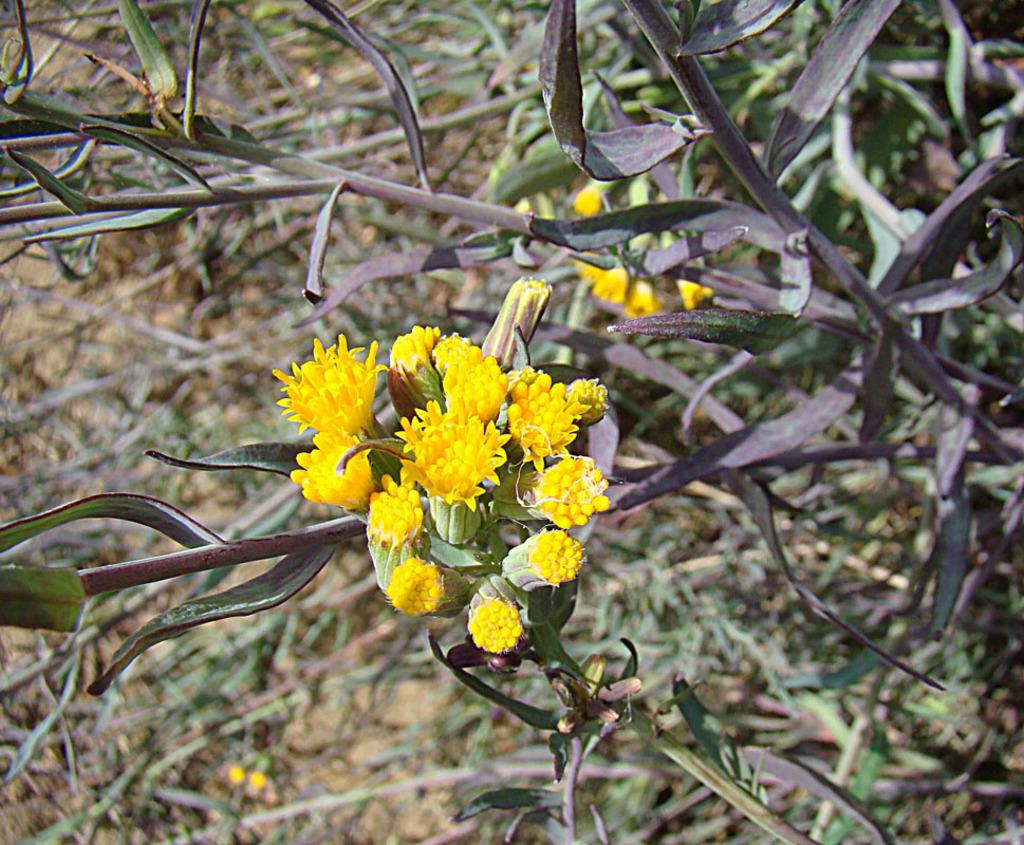What type of living organism can be seen in the image? There is a plant in the image. What specific feature of the plant is visible? The plant has flowers. Where is the plant located in relation to the image? The plant is in the foreground of the image. What letter can be seen on the petals of the flowers in the image? There are no letters visible on the petals of the flowers in the image. Can you tell me how many bees are buzzing around the plant in the image? There are no bees present in the image; it only features a plant with flowers. 